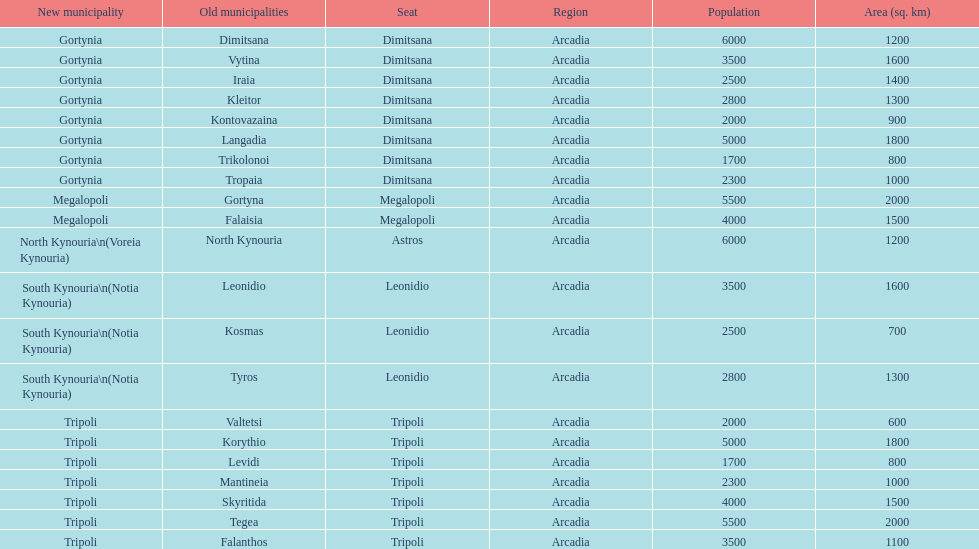What is the new municipality of tyros? South Kynouria. 